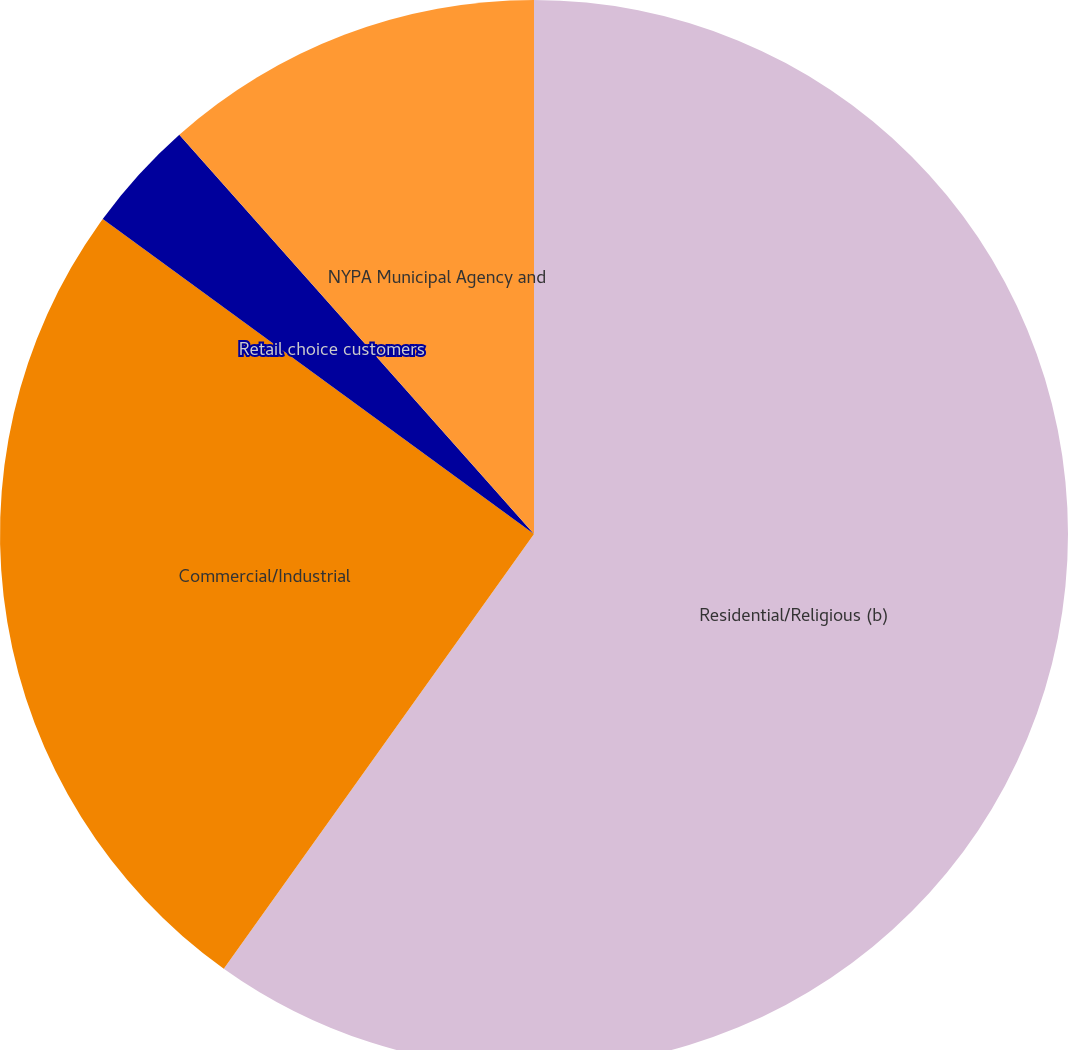Convert chart to OTSL. <chart><loc_0><loc_0><loc_500><loc_500><pie_chart><fcel>Residential/Religious (b)<fcel>Commercial/Industrial<fcel>Retail choice customers<fcel>NYPA Municipal Agency and<nl><fcel>59.86%<fcel>25.17%<fcel>3.4%<fcel>11.56%<nl></chart> 